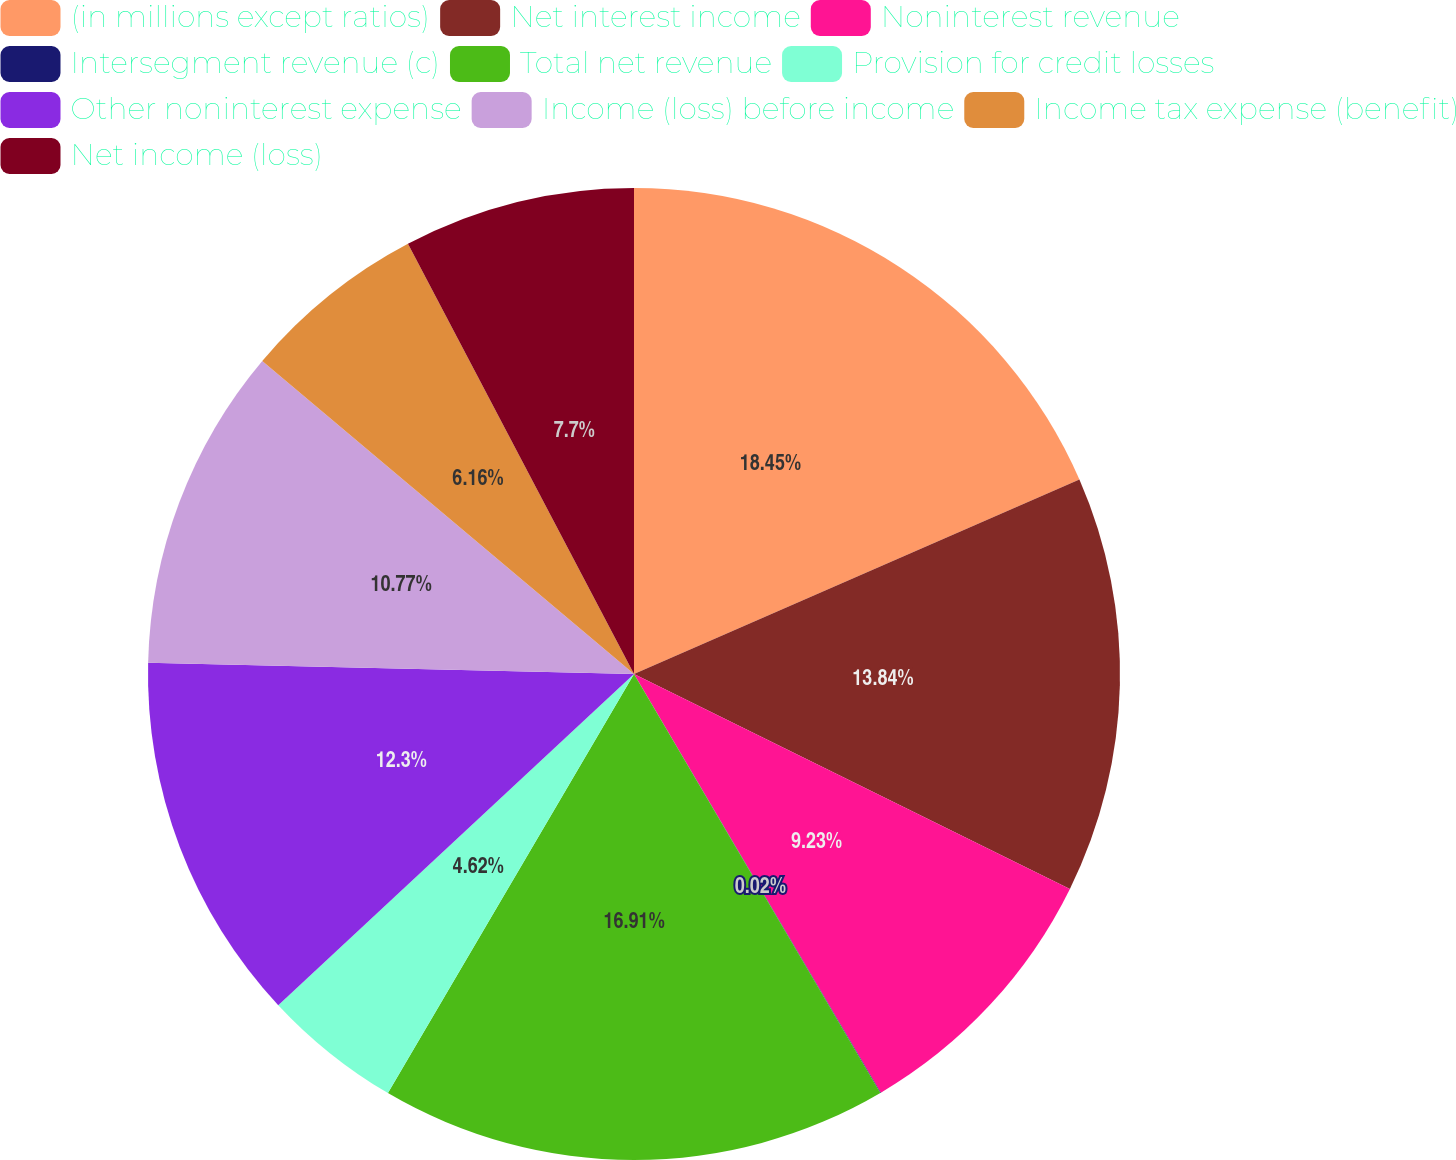<chart> <loc_0><loc_0><loc_500><loc_500><pie_chart><fcel>(in millions except ratios)<fcel>Net interest income<fcel>Noninterest revenue<fcel>Intersegment revenue (c)<fcel>Total net revenue<fcel>Provision for credit losses<fcel>Other noninterest expense<fcel>Income (loss) before income<fcel>Income tax expense (benefit)<fcel>Net income (loss)<nl><fcel>18.45%<fcel>13.84%<fcel>9.23%<fcel>0.02%<fcel>16.91%<fcel>4.62%<fcel>12.3%<fcel>10.77%<fcel>6.16%<fcel>7.7%<nl></chart> 